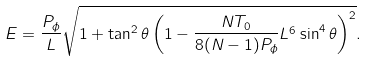Convert formula to latex. <formula><loc_0><loc_0><loc_500><loc_500>E = \frac { P _ { \phi } } { L } \sqrt { 1 + \tan ^ { 2 } { \theta } \left ( 1 - { \frac { N T _ { 0 } } { 8 ( N - 1 ) P _ { \phi } } } L ^ { 6 } \sin ^ { 4 } { \theta } \right ) ^ { 2 } } .</formula> 